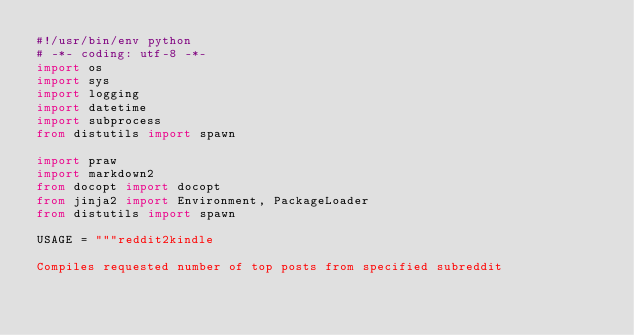<code> <loc_0><loc_0><loc_500><loc_500><_Python_>#!/usr/bin/env python
# -*- coding: utf-8 -*-
import os
import sys
import logging
import datetime
import subprocess
from distutils import spawn

import praw
import markdown2
from docopt import docopt
from jinja2 import Environment, PackageLoader
from distutils import spawn

USAGE = """reddit2kindle

Compiles requested number of top posts from specified subreddit</code> 